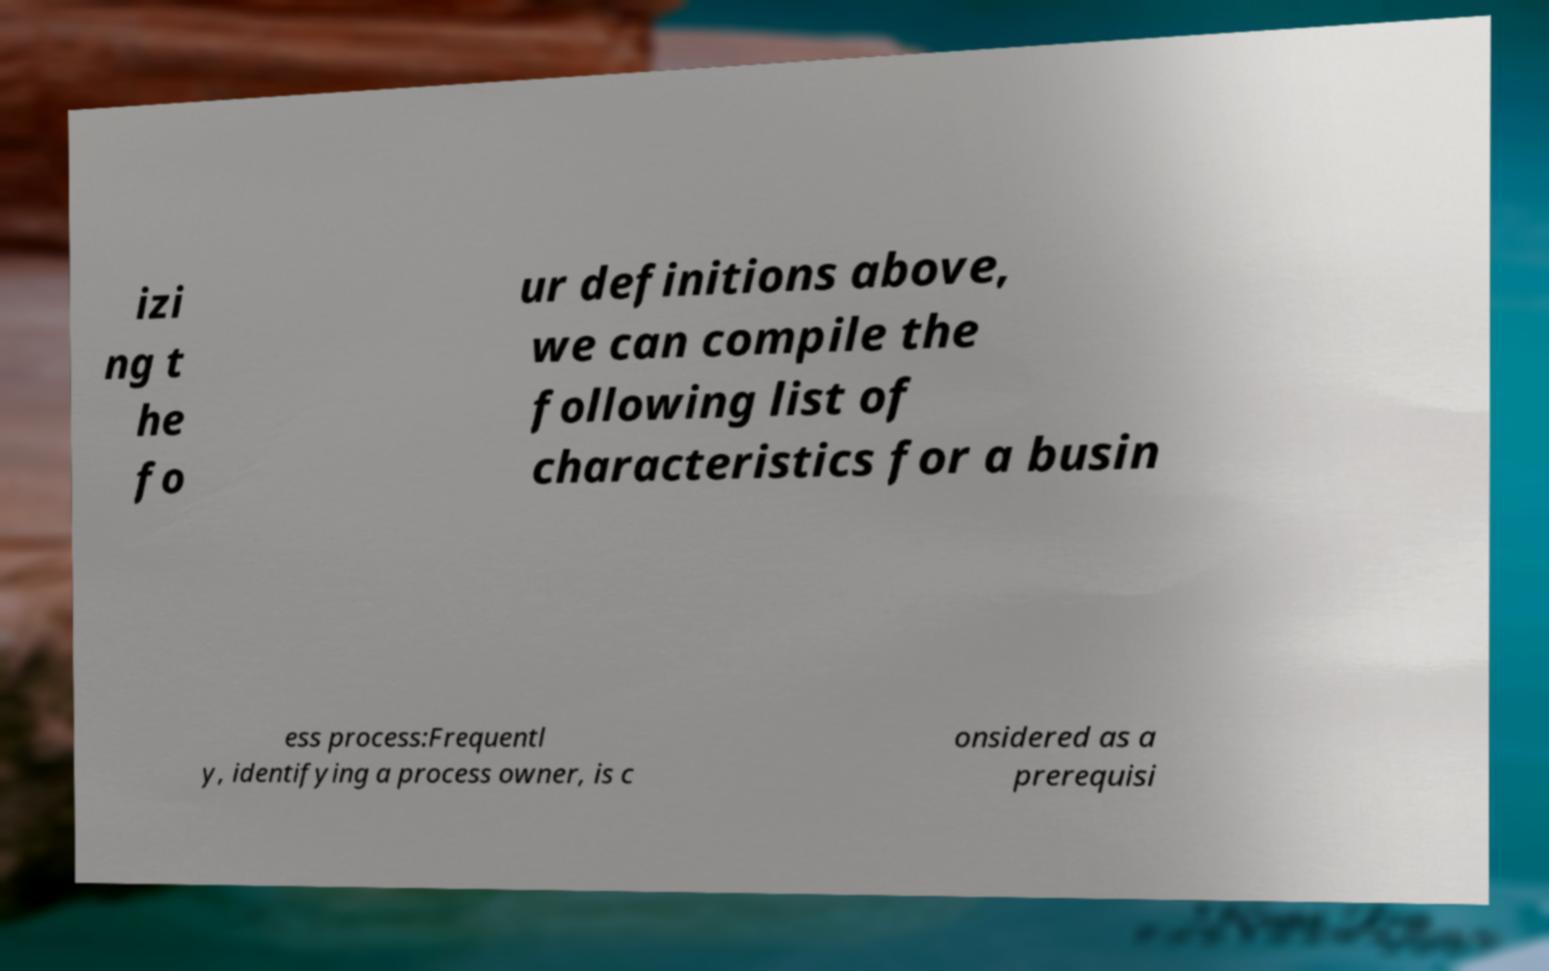There's text embedded in this image that I need extracted. Can you transcribe it verbatim? izi ng t he fo ur definitions above, we can compile the following list of characteristics for a busin ess process:Frequentl y, identifying a process owner, is c onsidered as a prerequisi 